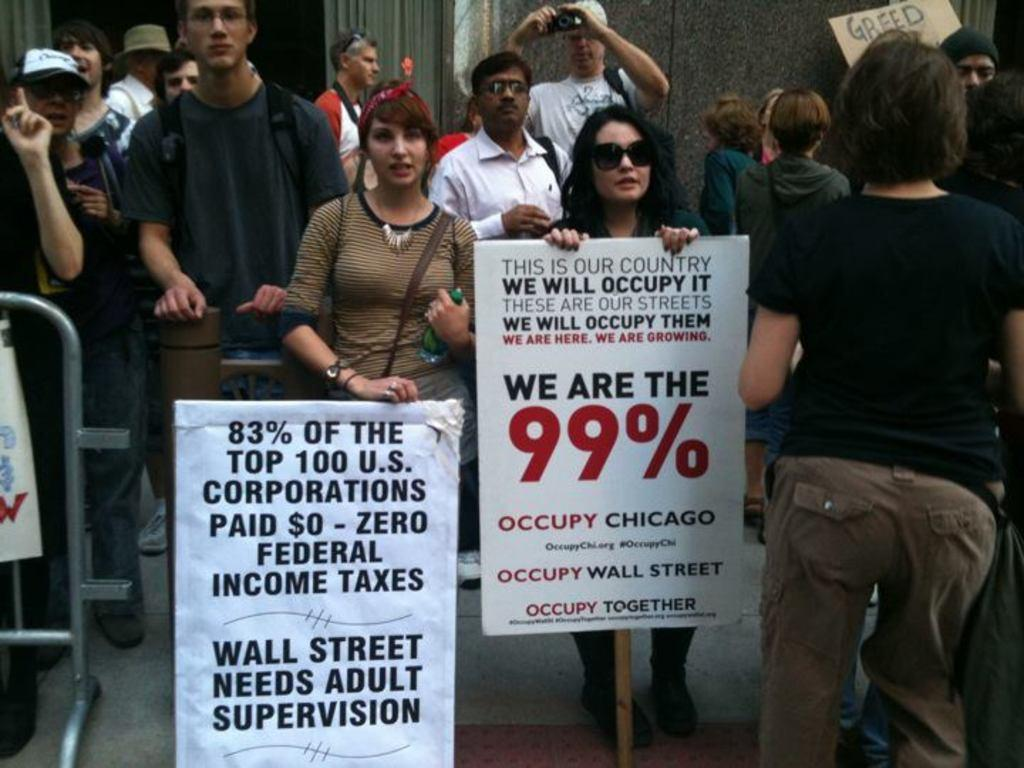How many people are in the image? There are people in the image, but the exact number is not specified. What is the woman holding in the image? The woman is holding a board in the image. What is the person holding next to the woman? A person is holding a bottle in the image. What is in front of the person holding the bottle? There is a banner in front of the person holding the bottle. What object can be seen in the image that is long and thin? There is a rod in the image. What can be seen in the background of the image? There is a wall in the background of the image. What type of powder is being sprinkled on the rose in the image? There is no rose or powder present in the image. 